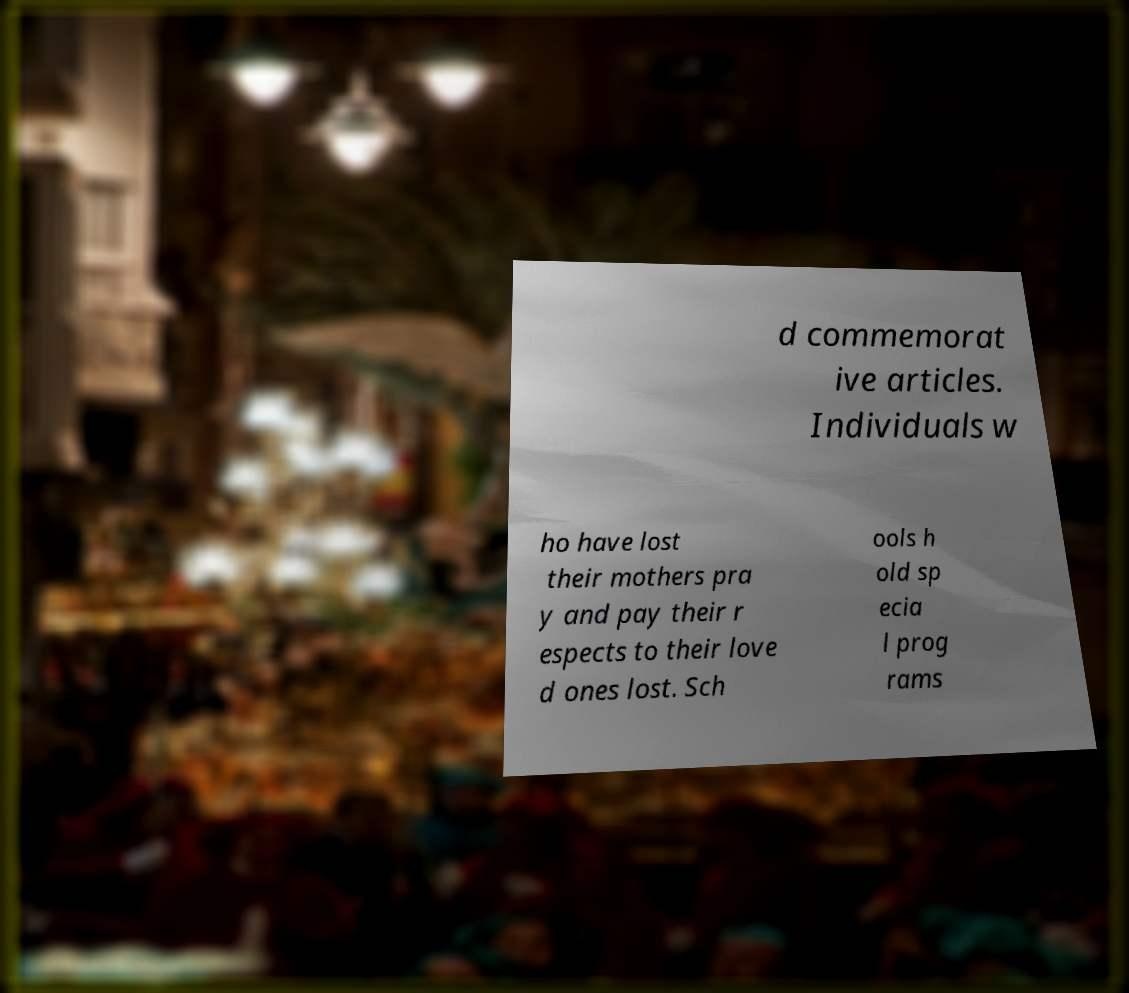Please read and relay the text visible in this image. What does it say? d commemorat ive articles. Individuals w ho have lost their mothers pra y and pay their r espects to their love d ones lost. Sch ools h old sp ecia l prog rams 